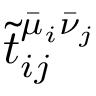Convert formula to latex. <formula><loc_0><loc_0><loc_500><loc_500>\tilde { t } _ { i j } ^ { \bar { \mu } _ { i } \bar { \nu } _ { j } }</formula> 